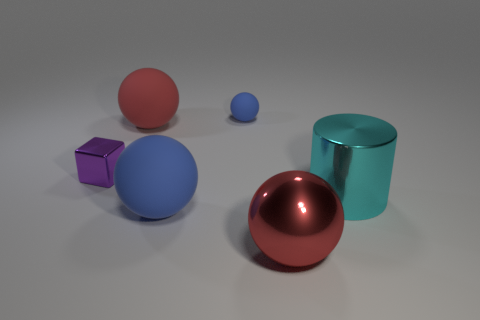How many other small rubber balls are the same color as the small ball?
Your response must be concise. 0. What size is the red ball on the left side of the blue object in front of the tiny shiny block?
Ensure brevity in your answer.  Large. What number of objects are either large matte objects that are behind the small purple metal thing or metallic things?
Give a very brief answer. 4. Are there any purple blocks that have the same size as the cyan thing?
Keep it short and to the point. No. There is a blue matte ball that is behind the cylinder; is there a tiny purple object that is behind it?
Ensure brevity in your answer.  No. What number of blocks are large cyan metal objects or rubber things?
Ensure brevity in your answer.  0. Are there any tiny metal things of the same shape as the large cyan metallic object?
Provide a succinct answer. No. What is the shape of the purple thing?
Make the answer very short. Cube. What number of objects are tiny matte objects or big brown rubber things?
Your response must be concise. 1. Do the red ball that is behind the large cylinder and the thing that is to the right of the metallic sphere have the same size?
Your answer should be very brief. Yes. 